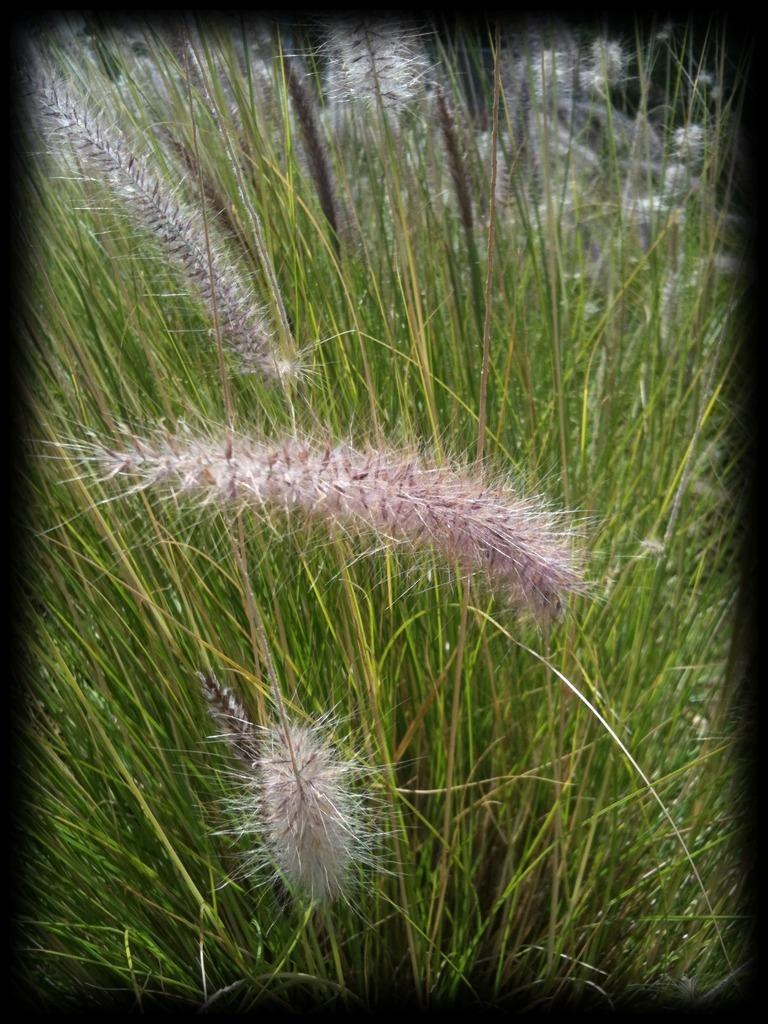What type of image is being described? The image is an edited picture. What can be observed on the plants in the image? There are white color flowers on the plants in the image. What type of dolls can be seen in the image? There are no dolls present in the image; it features white flowers on plants. What season is depicted in the image? The image does not depict a specific season, as it only shows white flowers on plants. 